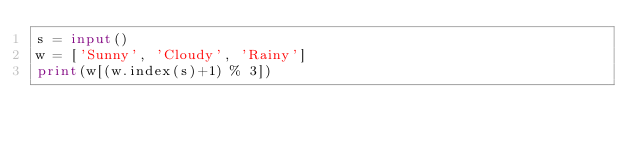Convert code to text. <code><loc_0><loc_0><loc_500><loc_500><_Python_>s = input()
w = ['Sunny', 'Cloudy', 'Rainy']
print(w[(w.index(s)+1) % 3])
</code> 